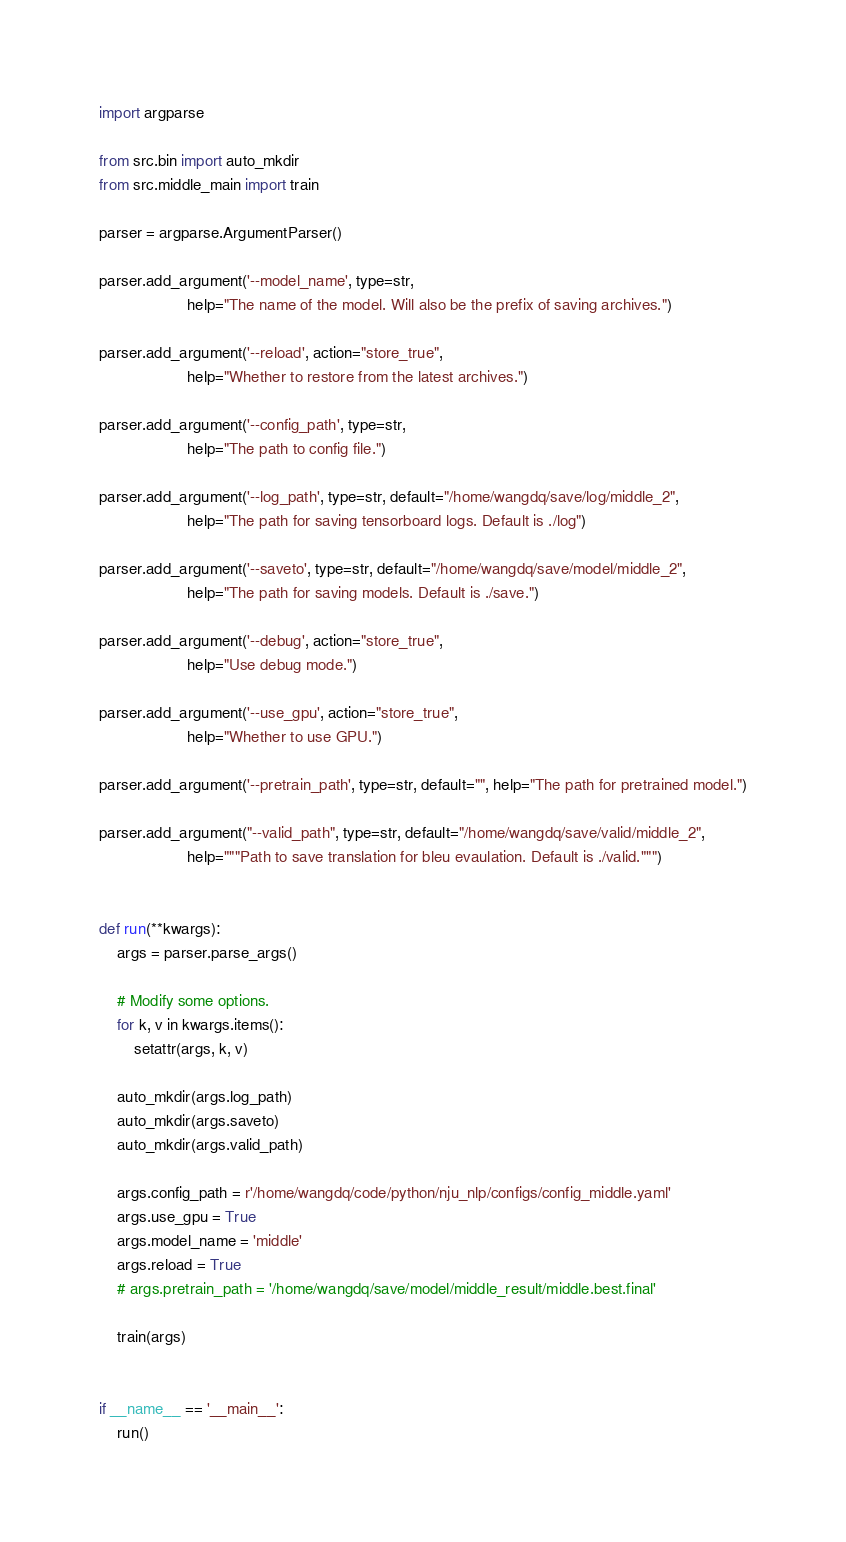Convert code to text. <code><loc_0><loc_0><loc_500><loc_500><_Python_>import argparse

from src.bin import auto_mkdir
from src.middle_main import train

parser = argparse.ArgumentParser()

parser.add_argument('--model_name', type=str,
                    help="The name of the model. Will also be the prefix of saving archives.")

parser.add_argument('--reload', action="store_true",
                    help="Whether to restore from the latest archives.")

parser.add_argument('--config_path', type=str,
                    help="The path to config file.")

parser.add_argument('--log_path', type=str, default="/home/wangdq/save/log/middle_2",
                    help="The path for saving tensorboard logs. Default is ./log")

parser.add_argument('--saveto', type=str, default="/home/wangdq/save/model/middle_2",
                    help="The path for saving models. Default is ./save.")

parser.add_argument('--debug', action="store_true",
                    help="Use debug mode.")

parser.add_argument('--use_gpu', action="store_true",
                    help="Whether to use GPU.")

parser.add_argument('--pretrain_path', type=str, default="", help="The path for pretrained model.")

parser.add_argument("--valid_path", type=str, default="/home/wangdq/save/valid/middle_2",
                    help="""Path to save translation for bleu evaulation. Default is ./valid.""")


def run(**kwargs):
    args = parser.parse_args()

    # Modify some options.
    for k, v in kwargs.items():
        setattr(args, k, v)

    auto_mkdir(args.log_path)
    auto_mkdir(args.saveto)
    auto_mkdir(args.valid_path)

    args.config_path = r'/home/wangdq/code/python/nju_nlp/configs/config_middle.yaml'
    args.use_gpu = True
    args.model_name = 'middle'
    args.reload = True
    # args.pretrain_path = '/home/wangdq/save/model/middle_result/middle.best.final'

    train(args)


if __name__ == '__main__':
    run()
</code> 